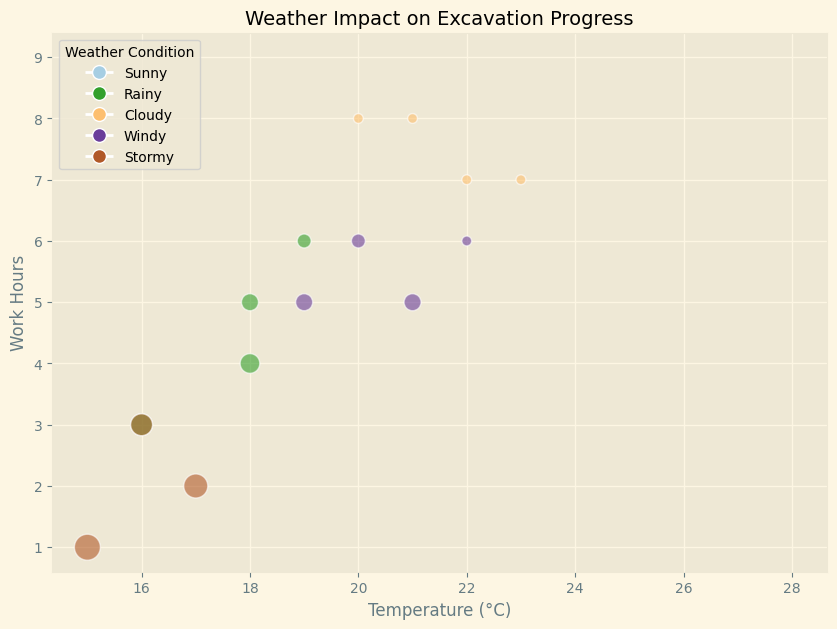How does the work hours change with increasing temperature under sunny conditions? To answer this, examine the data points for sunny conditions. Notice that the temperatures are increasing from 24°C to 28°C, along with consistent work hours around 8 or 9 hours.
Answer: It remains fairly consistent, varies between 8-9 hours Which weather condition results in the maximum delay, and what is the temperature associated with it? Identify the largest bubble in the plot, which represents the maximum delay. The largest bubbles are found under stormy conditions. Check the temperatures for these points; the highest delay (7 hours) is associated with 15°C.
Answer: Stormy, 15°C Compare the work hours for windy and stormy conditions. Which one generally has lower work hours? Look at the data points corresponding to windy and stormy conditions. Note their vertical positions, representing work hours. Observe that stormy conditions generally have work hours between 1-3 hours, while windy conditions have work hours between 5-6 hours.
Answer: Stormy conditions What's the average delay for rainy conditions? First, locate all data points for rainy conditions. Identify their bubble sizes (each representing delay). Summing the delays: 3 + 5 + 2 + 4 = 14 hours. There are four data points, so the average is 14/4.
Answer: 3.5 hours Which two conditions show the highest variability in work hours and what are their work hour ranges? Look for the range (difference between maximum and minimum work hours) for each condition. Windy ranges from 5 to 6 hours (1-hour range) and stormy from 1 to 3 hours (2-hour range), while others are more variable like rainy ranging from 3 to 6 hours (3-hour range). Cloudy and sunny conditions do not show high variability in work hours compared to rainy and stormy conditions.
Answer: Rainy: 3 to 6 hours, Stormy: 1 to 3 hours For which weather condition, the bubbles are smallest, and what does it imply? Find the smallest bubbles in the plot, which represent the lowest delays. These small bubbles are under sunny conditions. This implies sunny conditions have minimal delays (0 hours).
Answer: Sunny; it implies minimum delays How does precipitation seem to affect the work hours? Compare the three conditions: rainy, stormy, and cloudy. Visualize average precipitation and work hours by looking at corresponding bubbles. Rainy conditions (more precipitation) have work hours from 3-6, stormy (highest) from 1-3, and cloudy (least) from 7-8. Higher precipitation tends to correlate with fewer work hours.
Answer: Higher precipitation correlates with fewer work hours 